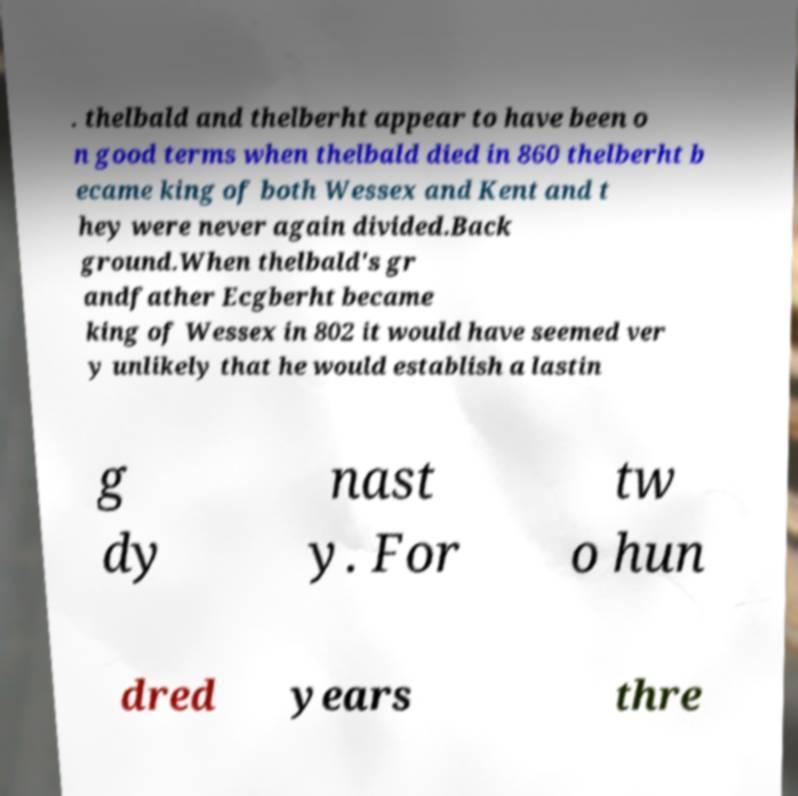Please identify and transcribe the text found in this image. . thelbald and thelberht appear to have been o n good terms when thelbald died in 860 thelberht b ecame king of both Wessex and Kent and t hey were never again divided.Back ground.When thelbald's gr andfather Ecgberht became king of Wessex in 802 it would have seemed ver y unlikely that he would establish a lastin g dy nast y. For tw o hun dred years thre 